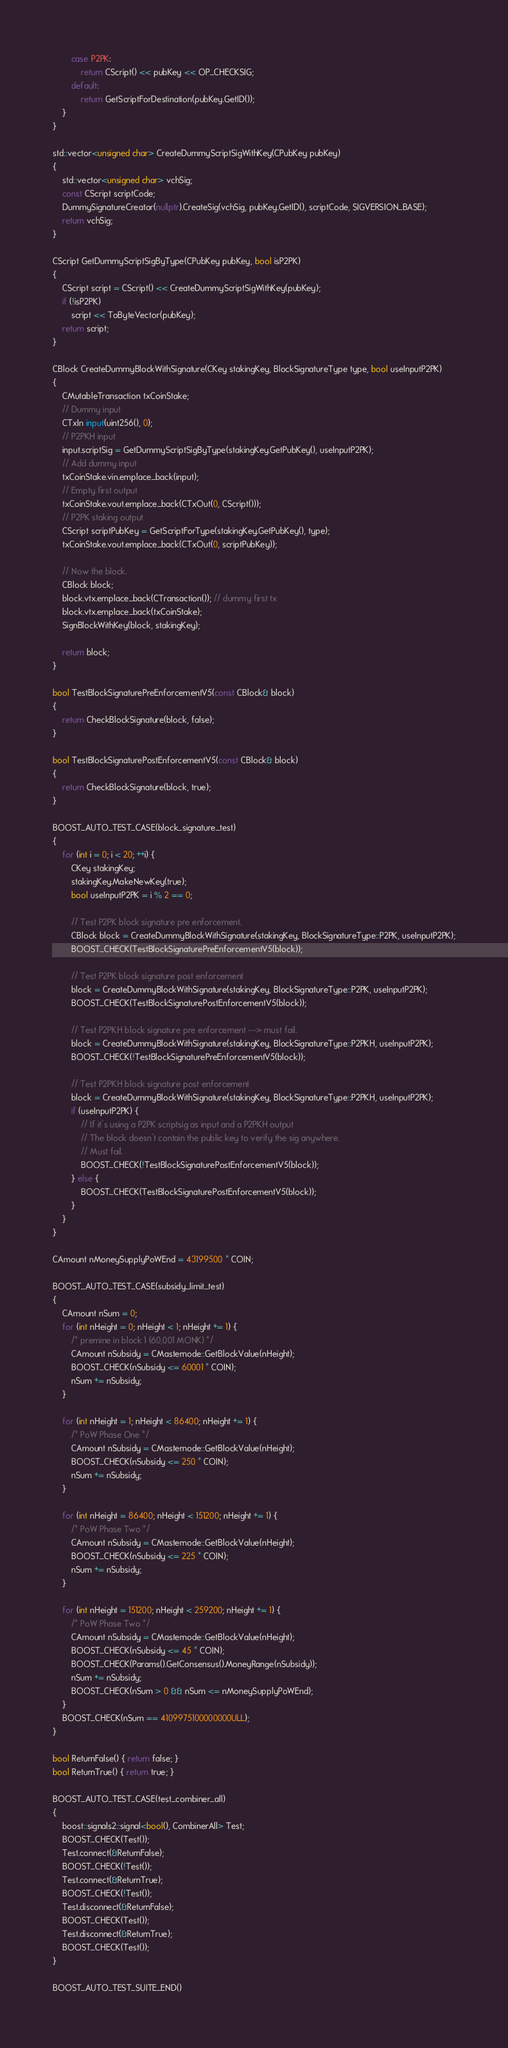<code> <loc_0><loc_0><loc_500><loc_500><_C++_>        case P2PK:
            return CScript() << pubKey << OP_CHECKSIG;
        default:
            return GetScriptForDestination(pubKey.GetID());
    }
}

std::vector<unsigned char> CreateDummyScriptSigWithKey(CPubKey pubKey)
{
    std::vector<unsigned char> vchSig;
    const CScript scriptCode;
    DummySignatureCreator(nullptr).CreateSig(vchSig, pubKey.GetID(), scriptCode, SIGVERSION_BASE);
    return vchSig;
}

CScript GetDummyScriptSigByType(CPubKey pubKey, bool isP2PK)
{
    CScript script = CScript() << CreateDummyScriptSigWithKey(pubKey);
    if (!isP2PK)
        script << ToByteVector(pubKey);
    return script;
}

CBlock CreateDummyBlockWithSignature(CKey stakingKey, BlockSignatureType type, bool useInputP2PK)
{
    CMutableTransaction txCoinStake;
    // Dummy input
    CTxIn input(uint256(), 0);
    // P2PKH input
    input.scriptSig = GetDummyScriptSigByType(stakingKey.GetPubKey(), useInputP2PK);
    // Add dummy input
    txCoinStake.vin.emplace_back(input);
    // Empty first output
    txCoinStake.vout.emplace_back(CTxOut(0, CScript()));
    // P2PK staking output
    CScript scriptPubKey = GetScriptForType(stakingKey.GetPubKey(), type);
    txCoinStake.vout.emplace_back(CTxOut(0, scriptPubKey));

    // Now the block.
    CBlock block;
    block.vtx.emplace_back(CTransaction()); // dummy first tx
    block.vtx.emplace_back(txCoinStake);
    SignBlockWithKey(block, stakingKey);

    return block;
}

bool TestBlockSignaturePreEnforcementV5(const CBlock& block)
{
    return CheckBlockSignature(block, false);
}

bool TestBlockSignaturePostEnforcementV5(const CBlock& block)
{
    return CheckBlockSignature(block, true);
}

BOOST_AUTO_TEST_CASE(block_signature_test)
{
    for (int i = 0; i < 20; ++i) {
        CKey stakingKey;
        stakingKey.MakeNewKey(true);
        bool useInputP2PK = i % 2 == 0;

        // Test P2PK block signature pre enforcement.
        CBlock block = CreateDummyBlockWithSignature(stakingKey, BlockSignatureType::P2PK, useInputP2PK);
        BOOST_CHECK(TestBlockSignaturePreEnforcementV5(block));

        // Test P2PK block signature post enforcement
        block = CreateDummyBlockWithSignature(stakingKey, BlockSignatureType::P2PK, useInputP2PK);
        BOOST_CHECK(TestBlockSignaturePostEnforcementV5(block));

        // Test P2PKH block signature pre enforcement ---> must fail.
        block = CreateDummyBlockWithSignature(stakingKey, BlockSignatureType::P2PKH, useInputP2PK);
        BOOST_CHECK(!TestBlockSignaturePreEnforcementV5(block));

        // Test P2PKH block signature post enforcement
        block = CreateDummyBlockWithSignature(stakingKey, BlockSignatureType::P2PKH, useInputP2PK);
        if (useInputP2PK) {
            // If it's using a P2PK scriptsig as input and a P2PKH output
            // The block doesn't contain the public key to verify the sig anywhere.
            // Must fail.
            BOOST_CHECK(!TestBlockSignaturePostEnforcementV5(block));
        } else {
            BOOST_CHECK(TestBlockSignaturePostEnforcementV5(block));
        }
    }
}

CAmount nMoneySupplyPoWEnd = 43199500 * COIN;

BOOST_AUTO_TEST_CASE(subsidy_limit_test)
{
    CAmount nSum = 0;
    for (int nHeight = 0; nHeight < 1; nHeight += 1) {
        /* premine in block 1 (60,001 MONK) */
        CAmount nSubsidy = CMasternode::GetBlockValue(nHeight);
        BOOST_CHECK(nSubsidy <= 60001 * COIN);
        nSum += nSubsidy;
    }

    for (int nHeight = 1; nHeight < 86400; nHeight += 1) {
        /* PoW Phase One */
        CAmount nSubsidy = CMasternode::GetBlockValue(nHeight);
        BOOST_CHECK(nSubsidy <= 250 * COIN);
        nSum += nSubsidy;
    }

    for (int nHeight = 86400; nHeight < 151200; nHeight += 1) {
        /* PoW Phase Two */
        CAmount nSubsidy = CMasternode::GetBlockValue(nHeight);
        BOOST_CHECK(nSubsidy <= 225 * COIN);
        nSum += nSubsidy;
    }

    for (int nHeight = 151200; nHeight < 259200; nHeight += 1) {
        /* PoW Phase Two */
        CAmount nSubsidy = CMasternode::GetBlockValue(nHeight);
        BOOST_CHECK(nSubsidy <= 45 * COIN);
        BOOST_CHECK(Params().GetConsensus().MoneyRange(nSubsidy));
        nSum += nSubsidy;
        BOOST_CHECK(nSum > 0 && nSum <= nMoneySupplyPoWEnd);
    }
    BOOST_CHECK(nSum == 4109975100000000ULL);
}

bool ReturnFalse() { return false; }
bool ReturnTrue() { return true; }

BOOST_AUTO_TEST_CASE(test_combiner_all)
{
    boost::signals2::signal<bool(), CombinerAll> Test;
    BOOST_CHECK(Test());
    Test.connect(&ReturnFalse);
    BOOST_CHECK(!Test());
    Test.connect(&ReturnTrue);
    BOOST_CHECK(!Test());
    Test.disconnect(&ReturnFalse);
    BOOST_CHECK(Test());
    Test.disconnect(&ReturnTrue);
    BOOST_CHECK(Test());
}

BOOST_AUTO_TEST_SUITE_END()
</code> 